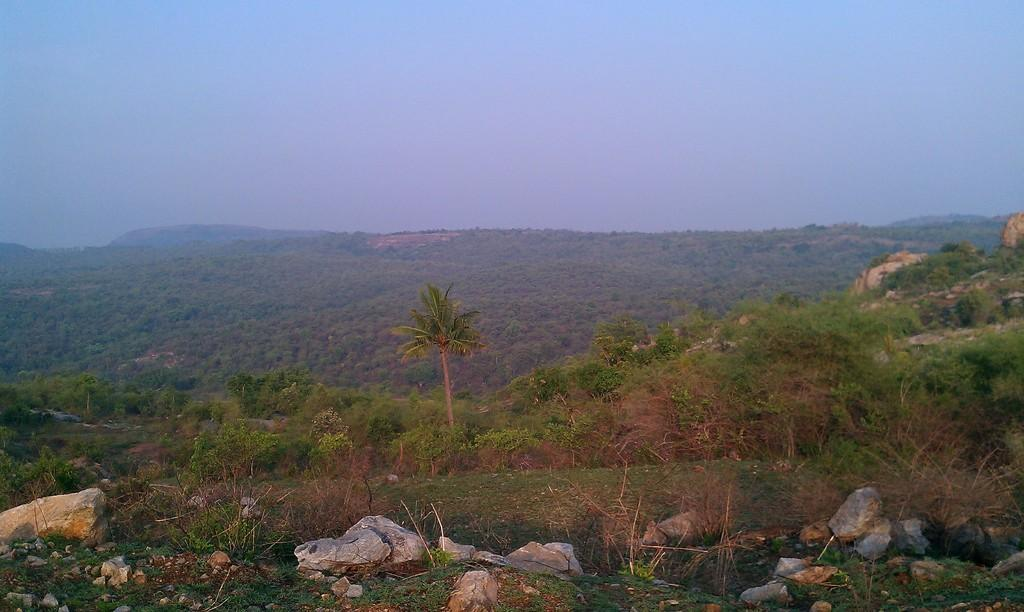What type of natural elements can be seen in the image? There are trees and rocks in the image. What is visible in the background of the image? The sky is visible in the background of the image. What type of substance is being coached by the card in the image? There is no substance, coach, or card present in the image. 